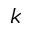<formula> <loc_0><loc_0><loc_500><loc_500>k</formula> 